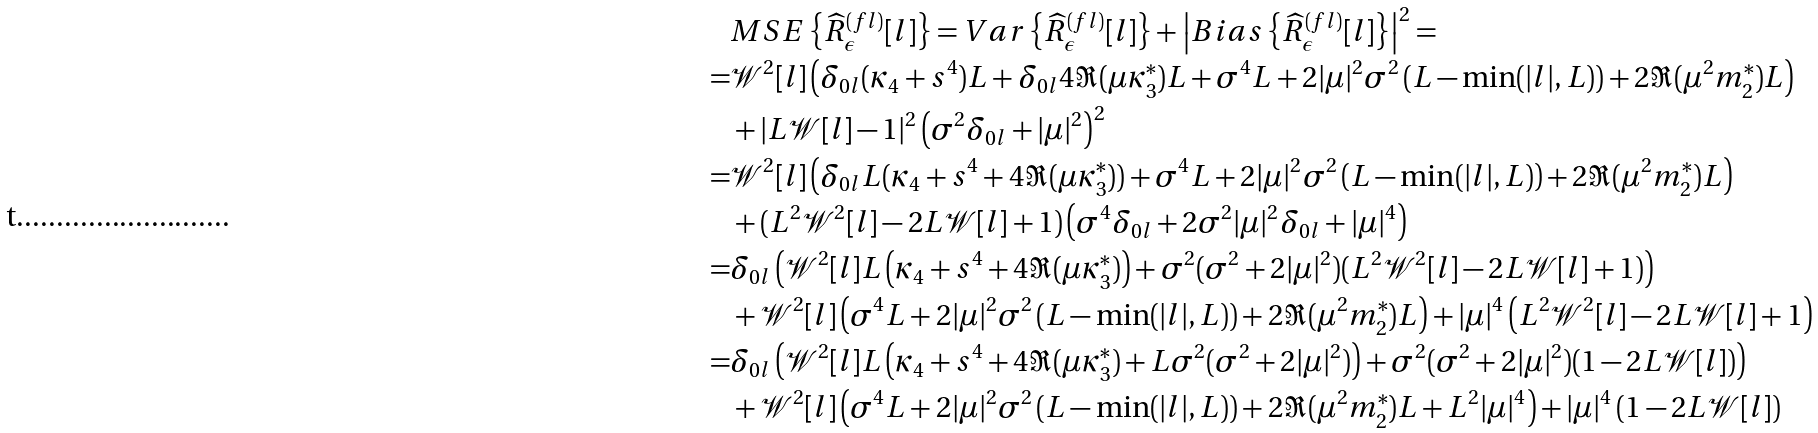Convert formula to latex. <formula><loc_0><loc_0><loc_500><loc_500>& M S E \left \{ \widehat { R } _ { \epsilon } ^ { ( f l ) } [ l ] \right \} = V a r \left \{ \widehat { R } _ { \epsilon } ^ { ( f l ) } [ l ] \right \} + \left | B i a s \left \{ \widehat { R } _ { \epsilon } ^ { ( f l ) } [ l ] \right \} \right | ^ { 2 } = \\ = & \mathcal { W } ^ { 2 } [ l ] \left ( \delta _ { 0 l } ( \kappa _ { 4 } + s ^ { 4 } ) L + \delta _ { 0 l } 4 \Re ( \mu \kappa _ { 3 } ^ { * } ) L + \sigma ^ { 4 } L + 2 | \mu | ^ { 2 } \sigma ^ { 2 } \left ( L - \min ( | l | , L ) \right ) + 2 \Re ( \mu ^ { 2 } m _ { 2 } ^ { * } ) L \right ) \\ & + | L \mathcal { W } [ l ] - 1 | ^ { 2 } \left ( \sigma ^ { 2 } \delta _ { 0 l } + | \mu | ^ { 2 } \right ) ^ { 2 } \\ = & \mathcal { W } ^ { 2 } [ l ] \left ( \delta _ { 0 l } L ( \kappa _ { 4 } + s ^ { 4 } + 4 \Re ( \mu \kappa _ { 3 } ^ { * } ) ) + \sigma ^ { 4 } L + 2 | \mu | ^ { 2 } \sigma ^ { 2 } \left ( L - \min ( | l | , L ) \right ) + 2 \Re ( \mu ^ { 2 } m _ { 2 } ^ { * } ) L \right ) \\ & + ( L ^ { 2 } \mathcal { W } ^ { 2 } [ l ] - 2 L \mathcal { W } [ l ] + 1 ) \left ( \sigma ^ { 4 } \delta _ { 0 l } + 2 \sigma ^ { 2 } | \mu | ^ { 2 } \delta _ { 0 l } + | \mu | ^ { 4 } \right ) \\ = & \delta _ { 0 l } \left ( \mathcal { W } ^ { 2 } [ l ] L \left ( \kappa _ { 4 } + s ^ { 4 } + 4 \Re ( \mu \kappa _ { 3 } ^ { * } ) \right ) + \sigma ^ { 2 } ( \sigma ^ { 2 } + 2 | \mu | ^ { 2 } ) ( L ^ { 2 } \mathcal { W } ^ { 2 } [ l ] - 2 L \mathcal { W } [ l ] + 1 ) \right ) \\ & + \mathcal { W } ^ { 2 } [ l ] \left ( \sigma ^ { 4 } L + 2 | \mu | ^ { 2 } \sigma ^ { 2 } \left ( L - \min ( | l | , L ) \right ) + 2 \Re ( \mu ^ { 2 } m _ { 2 } ^ { * } ) L \right ) + | \mu | ^ { 4 } \left ( L ^ { 2 } \mathcal { W } ^ { 2 } [ l ] - 2 L \mathcal { W } [ l ] + 1 \right ) \\ = & \delta _ { 0 l } \left ( \mathcal { W } ^ { 2 } [ l ] L \left ( \kappa _ { 4 } + s ^ { 4 } + 4 \Re ( \mu \kappa _ { 3 } ^ { * } ) + L \sigma ^ { 2 } ( \sigma ^ { 2 } + 2 | \mu | ^ { 2 } ) \right ) + \sigma ^ { 2 } ( \sigma ^ { 2 } + 2 | \mu | ^ { 2 } ) ( 1 - 2 L \mathcal { W } [ l ] ) \right ) \\ & + \mathcal { W } ^ { 2 } [ l ] \left ( \sigma ^ { 4 } L + 2 | \mu | ^ { 2 } \sigma ^ { 2 } \left ( L - \min ( | l | , L ) \right ) + 2 \Re ( \mu ^ { 2 } m _ { 2 } ^ { * } ) L + L ^ { 2 } | \mu | ^ { 4 } \right ) + | \mu | ^ { 4 } \left ( 1 - 2 L \mathcal { W } [ l ] \right )</formula> 